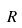<formula> <loc_0><loc_0><loc_500><loc_500>R</formula> 